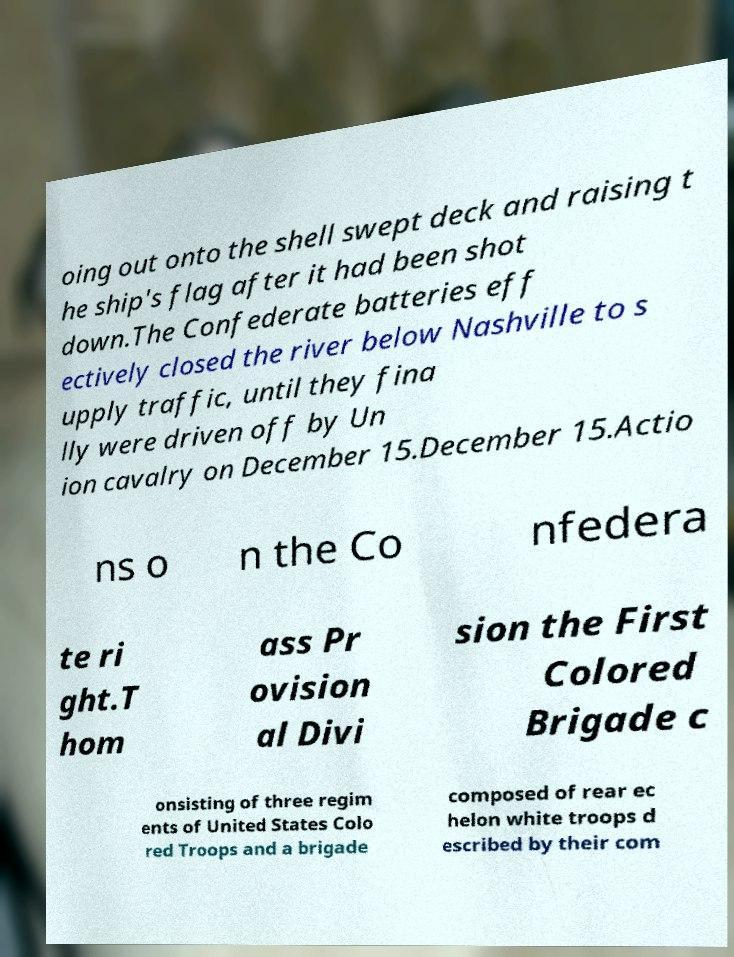Can you read and provide the text displayed in the image?This photo seems to have some interesting text. Can you extract and type it out for me? oing out onto the shell swept deck and raising t he ship's flag after it had been shot down.The Confederate batteries eff ectively closed the river below Nashville to s upply traffic, until they fina lly were driven off by Un ion cavalry on December 15.December 15.Actio ns o n the Co nfedera te ri ght.T hom ass Pr ovision al Divi sion the First Colored Brigade c onsisting of three regim ents of United States Colo red Troops and a brigade composed of rear ec helon white troops d escribed by their com 